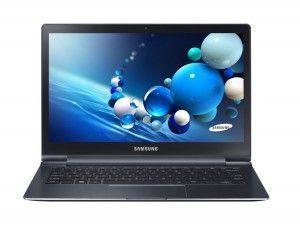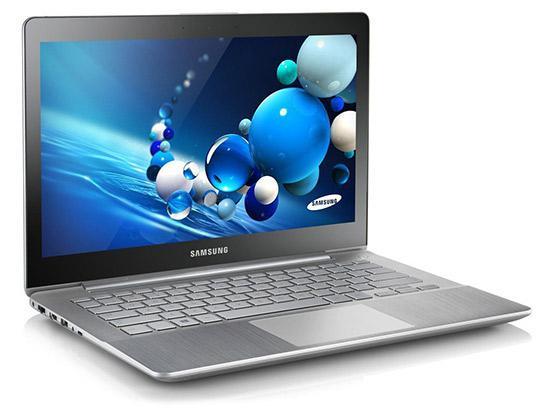The first image is the image on the left, the second image is the image on the right. Analyze the images presented: Is the assertion "The right image contains three or more computers." valid? Answer yes or no. No. The first image is the image on the left, the second image is the image on the right. Considering the images on both sides, is "Right image shows more devices with screens than left image." valid? Answer yes or no. No. 